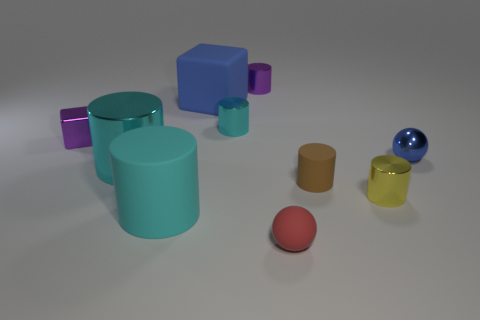How big is the rubber thing that is both to the right of the purple cylinder and behind the matte ball?
Make the answer very short. Small. There is a small cyan metal object; what shape is it?
Keep it short and to the point. Cylinder. How many things are either cyan cubes or small spheres that are in front of the large cyan shiny cylinder?
Your response must be concise. 1. Is the color of the small sphere to the right of the tiny red matte sphere the same as the matte cube?
Provide a succinct answer. Yes. The matte object that is on the left side of the small rubber sphere and in front of the big blue matte object is what color?
Provide a succinct answer. Cyan. What material is the cyan cylinder that is behind the blue sphere?
Your answer should be very brief. Metal. How big is the purple shiny block?
Offer a terse response. Small. What number of red things are either small matte balls or metallic blocks?
Ensure brevity in your answer.  1. What size is the ball that is to the left of the blue object right of the rubber ball?
Keep it short and to the point. Small. There is a large metal object; does it have the same color as the rubber cylinder on the left side of the tiny rubber ball?
Give a very brief answer. Yes. 